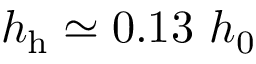<formula> <loc_0><loc_0><loc_500><loc_500>h _ { h } \simeq 0 . 1 3 h _ { 0 }</formula> 